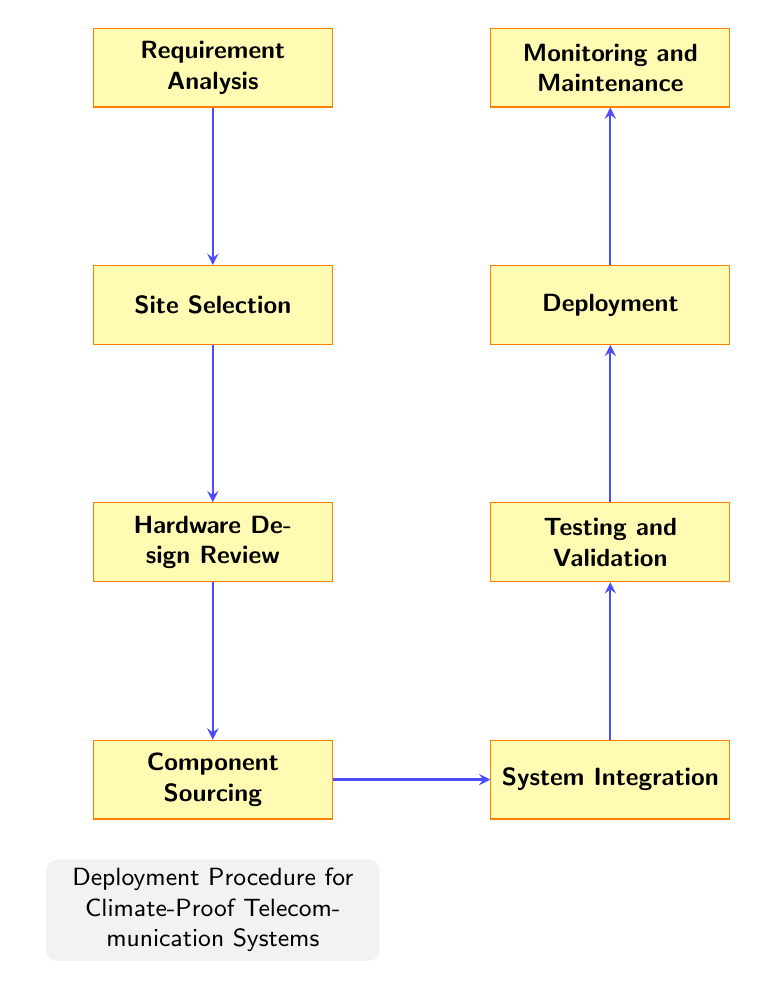What is the first step in the deployment procedure? The first step is indicated by the top node in the flow chart, which is labeled "Requirement Analysis."
Answer: Requirement Analysis How many total nodes are there in the diagram? By counting all the nodes displayed in the flow chart, there are eight distinct nodes listed from Requirement Analysis to Monitoring and Maintenance.
Answer: Eight What process follows "Component Sourcing"? After "Component Sourcing," the next process indicated in the flow chart is "System Integration," which is to the right of it.
Answer: System Integration What is the last step in the procedure? The last step is represented by the final node in the flow chart, which is "Monitoring and Maintenance."
Answer: Monitoring and Maintenance What are the two processes that occur before deployment? The processes that occur before "Deployment," indicated in the flow chart, are "Testing and Validation" and "System Integration."
Answer: Testing and Validation, System Integration Which two processes are directly connected? The processes "Testing and Validation" and "Deployment" are directly connected, as "Testing and Validation" leads into "Deployment" in the flow chart.
Answer: Testing and Validation, Deployment How does "Hardware Design Review" relate to "Site Selection"? "Hardware Design Review" follows "Site Selection" directly, indicating that it comes after assessing the site needs, making it a subsequent task in the procedure.
Answer: Follows directly What is the significance of "Monitoring and Maintenance" in the deployment procedure? "Monitoring and Maintenance" is significant as it ensures the continuous operation of the telecommunication systems after deployment, representing ongoing support required for climate-proof systems.
Answer: Continuous operation What step comes before "Testing and Validation"? The step immediately preceding "Testing and Validation" is "System Integration," indicating the integration of hardware before testing.
Answer: System Integration 